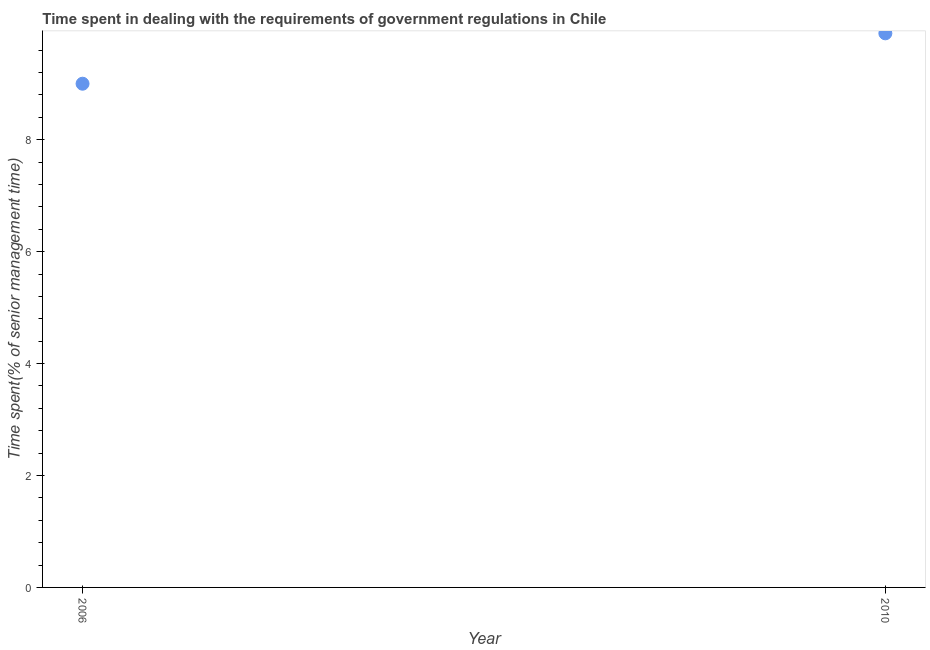Across all years, what is the minimum time spent in dealing with government regulations?
Offer a very short reply. 9. In which year was the time spent in dealing with government regulations maximum?
Make the answer very short. 2010. What is the difference between the time spent in dealing with government regulations in 2006 and 2010?
Your answer should be compact. -0.9. What is the average time spent in dealing with government regulations per year?
Offer a very short reply. 9.45. What is the median time spent in dealing with government regulations?
Give a very brief answer. 9.45. In how many years, is the time spent in dealing with government regulations greater than 0.4 %?
Keep it short and to the point. 2. What is the ratio of the time spent in dealing with government regulations in 2006 to that in 2010?
Your answer should be compact. 0.91. In how many years, is the time spent in dealing with government regulations greater than the average time spent in dealing with government regulations taken over all years?
Ensure brevity in your answer.  1. Does the time spent in dealing with government regulations monotonically increase over the years?
Your response must be concise. Yes. How many years are there in the graph?
Your answer should be compact. 2. What is the title of the graph?
Your answer should be very brief. Time spent in dealing with the requirements of government regulations in Chile. What is the label or title of the Y-axis?
Provide a short and direct response. Time spent(% of senior management time). What is the Time spent(% of senior management time) in 2006?
Give a very brief answer. 9. What is the ratio of the Time spent(% of senior management time) in 2006 to that in 2010?
Your answer should be compact. 0.91. 